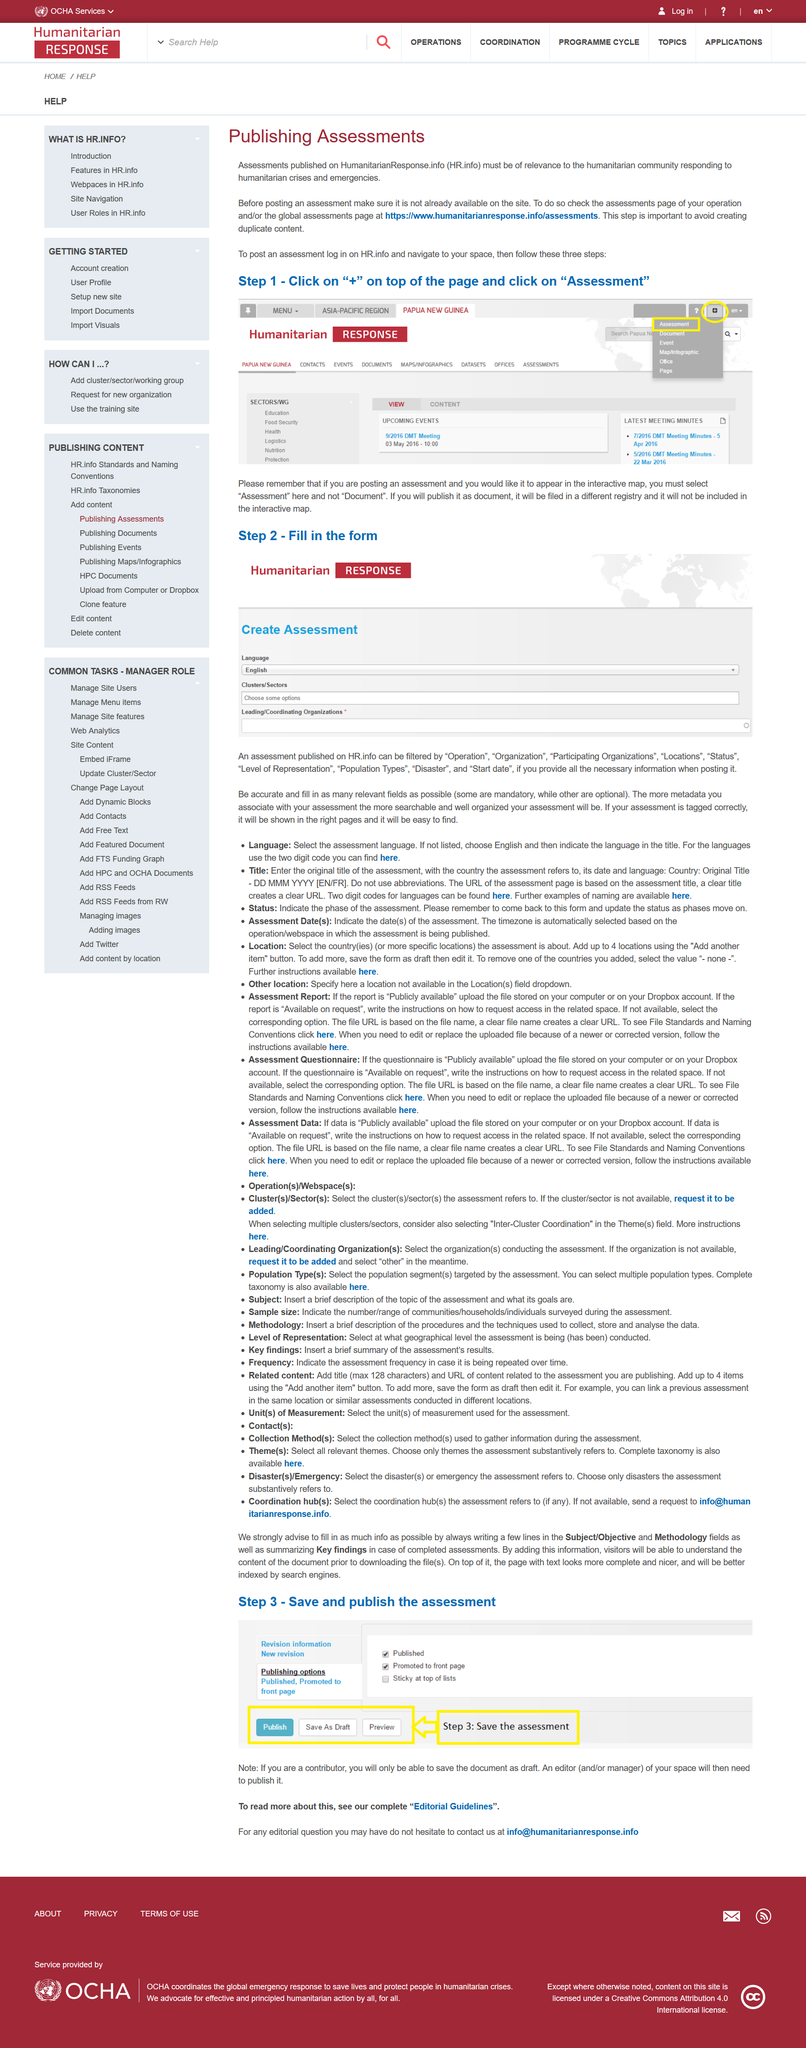Give some essential details in this illustration. The first step to post an assessment after logging in and navigating to your space is to click on the "+" button located at the top of the page and select "Assessment" from the dropdown menu. For an assessment to be published on HumanitarianResponse.info, it must be relevant to the humanitarian community responding to crises and emergencies and not already available on the site. It is possible to determine if an assessment is already available by checking the assessments page of one's operation and/or the global assessments page at <https://www.humanitarianresponse.info/assessments>. 